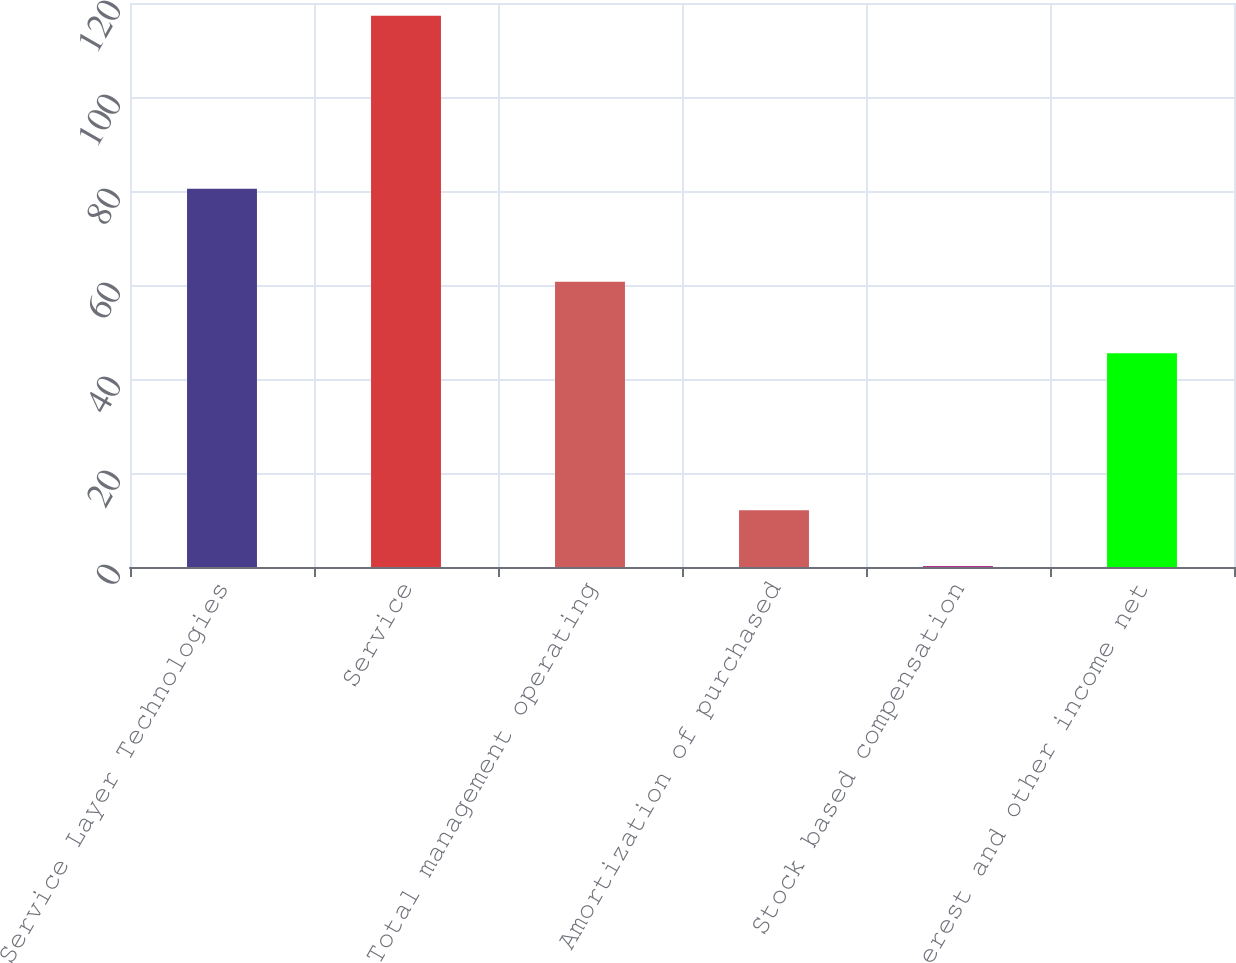Convert chart to OTSL. <chart><loc_0><loc_0><loc_500><loc_500><bar_chart><fcel>Service Layer Technologies<fcel>Service<fcel>Total management operating<fcel>Amortization of purchased<fcel>Stock based compensation<fcel>Interest and other income net<nl><fcel>80.5<fcel>117.3<fcel>60.7<fcel>12.1<fcel>0.2<fcel>45.5<nl></chart> 